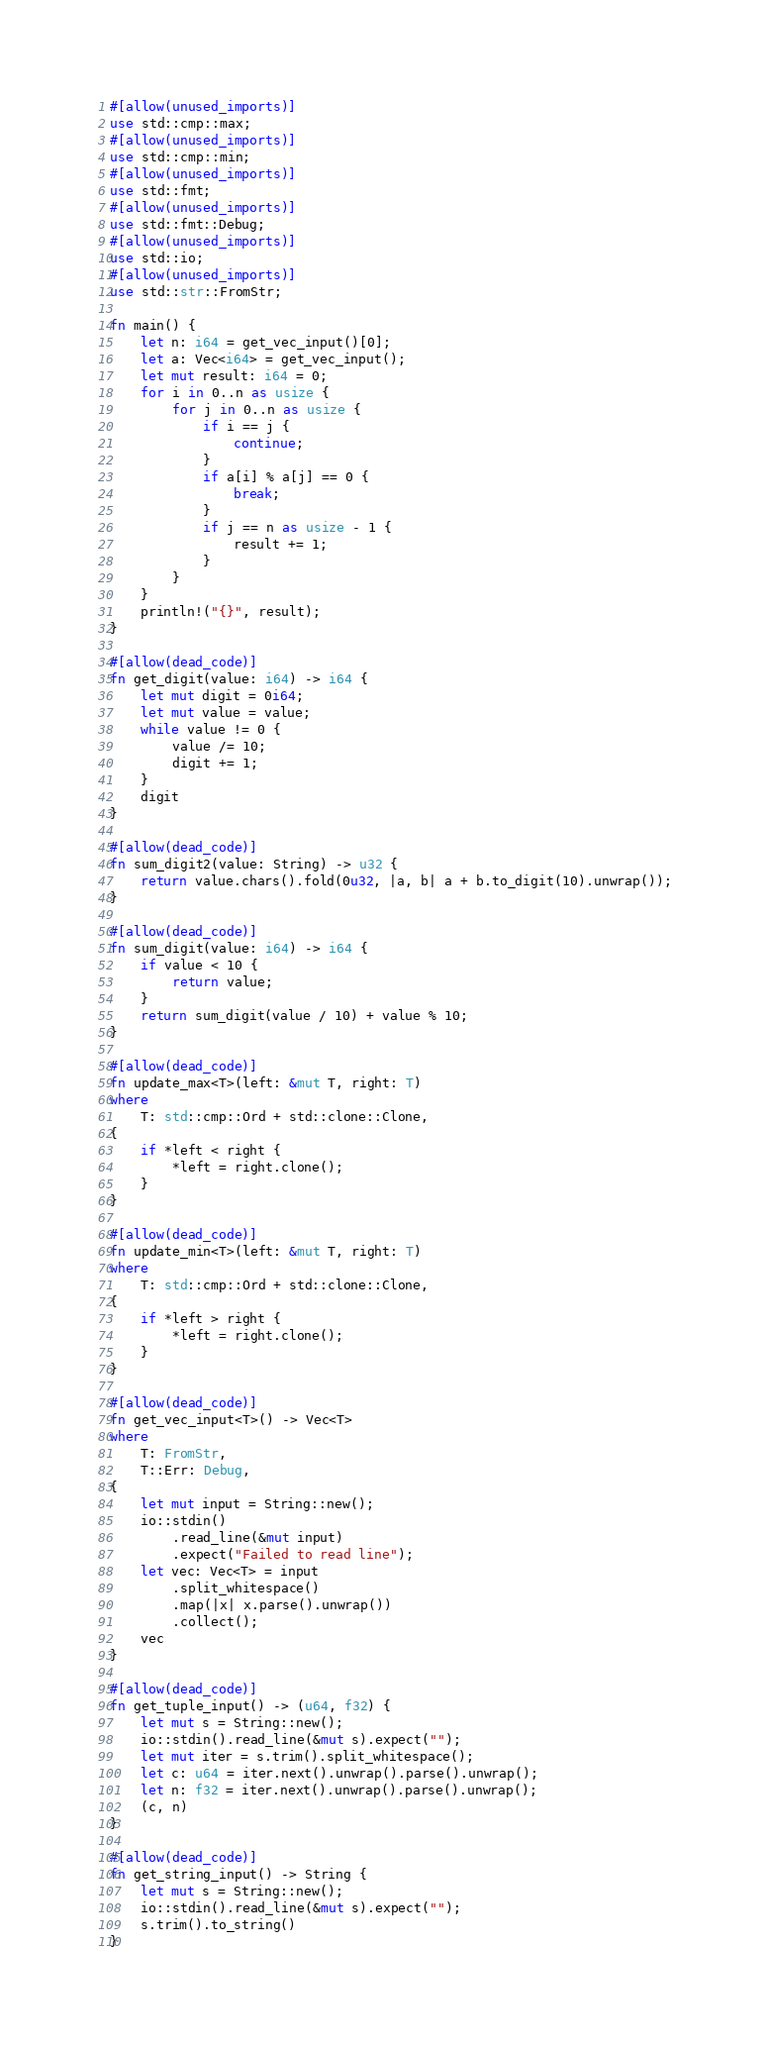Convert code to text. <code><loc_0><loc_0><loc_500><loc_500><_Rust_>#[allow(unused_imports)]
use std::cmp::max;
#[allow(unused_imports)]
use std::cmp::min;
#[allow(unused_imports)]
use std::fmt;
#[allow(unused_imports)]
use std::fmt::Debug;
#[allow(unused_imports)]
use std::io;
#[allow(unused_imports)]
use std::str::FromStr;

fn main() {
    let n: i64 = get_vec_input()[0];
    let a: Vec<i64> = get_vec_input();
    let mut result: i64 = 0;
    for i in 0..n as usize {
        for j in 0..n as usize {
            if i == j {
                continue;
            }
            if a[i] % a[j] == 0 {
                break;
            }
            if j == n as usize - 1 {
                result += 1;
            }
        }
    }
    println!("{}", result);
}

#[allow(dead_code)]
fn get_digit(value: i64) -> i64 {
    let mut digit = 0i64;
    let mut value = value;
    while value != 0 {
        value /= 10;
        digit += 1;
    }
    digit
}

#[allow(dead_code)]
fn sum_digit2(value: String) -> u32 {
    return value.chars().fold(0u32, |a, b| a + b.to_digit(10).unwrap());
}

#[allow(dead_code)]
fn sum_digit(value: i64) -> i64 {
    if value < 10 {
        return value;
    }
    return sum_digit(value / 10) + value % 10;
}

#[allow(dead_code)]
fn update_max<T>(left: &mut T, right: T)
where
    T: std::cmp::Ord + std::clone::Clone,
{
    if *left < right {
        *left = right.clone();
    }
}

#[allow(dead_code)]
fn update_min<T>(left: &mut T, right: T)
where
    T: std::cmp::Ord + std::clone::Clone,
{
    if *left > right {
        *left = right.clone();
    }
}

#[allow(dead_code)]
fn get_vec_input<T>() -> Vec<T>
where
    T: FromStr,
    T::Err: Debug,
{
    let mut input = String::new();
    io::stdin()
        .read_line(&mut input)
        .expect("Failed to read line");
    let vec: Vec<T> = input
        .split_whitespace()
        .map(|x| x.parse().unwrap())
        .collect();
    vec
}

#[allow(dead_code)]
fn get_tuple_input() -> (u64, f32) {
    let mut s = String::new();
    io::stdin().read_line(&mut s).expect("");
    let mut iter = s.trim().split_whitespace();
    let c: u64 = iter.next().unwrap().parse().unwrap();
    let n: f32 = iter.next().unwrap().parse().unwrap();
    (c, n)
}

#[allow(dead_code)]
fn get_string_input() -> String {
    let mut s = String::new();
    io::stdin().read_line(&mut s).expect("");
    s.trim().to_string()
}
</code> 